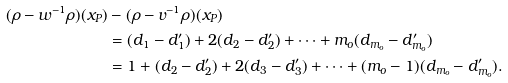Convert formula to latex. <formula><loc_0><loc_0><loc_500><loc_500>( \rho - w ^ { - 1 } \rho ) ( x _ { P } ) & - ( \rho - v ^ { - 1 } \rho ) ( x _ { P } ) \\ & = ( d _ { 1 } - d ^ { \prime } _ { 1 } ) + 2 ( d _ { 2 } - d ^ { \prime } _ { 2 } ) + \cdots + m _ { o } ( d _ { m _ { o } } - d ^ { \prime } _ { m _ { o } } ) \\ & = 1 + ( d _ { 2 } - d ^ { \prime } _ { 2 } ) + 2 ( d _ { 3 } - d ^ { \prime } _ { 3 } ) + \cdots + ( m _ { o } - 1 ) ( d _ { m _ { o } } - d ^ { \prime } _ { m _ { o } } ) .</formula> 